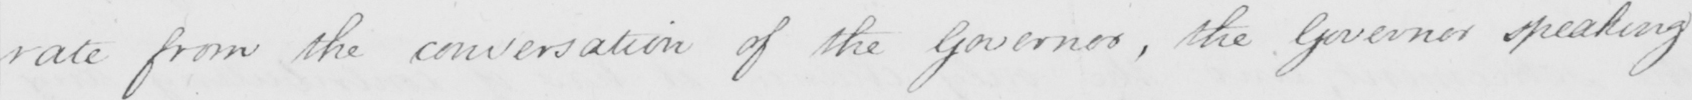Can you read and transcribe this handwriting? rate from the conversation of the Governor , the Governor speaking 